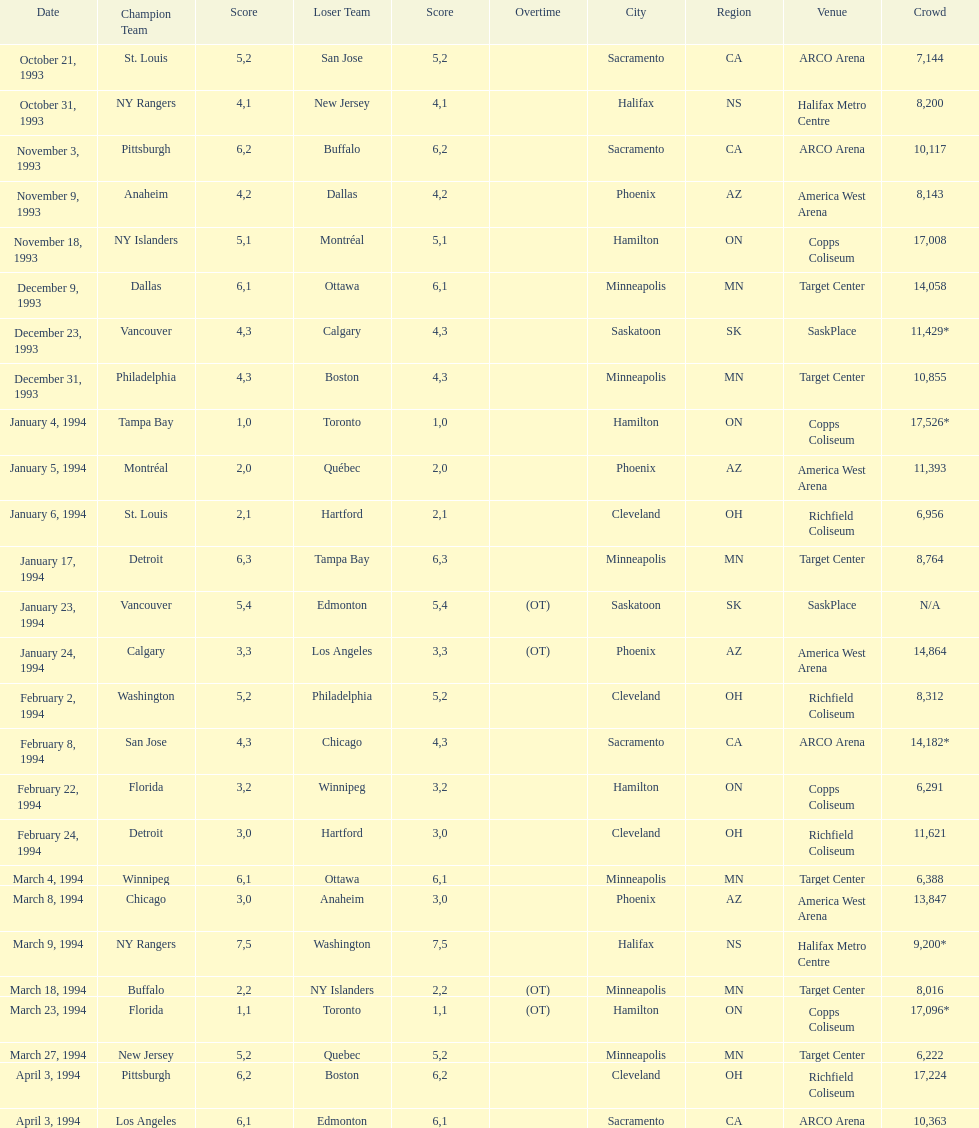Who won the game the day before the january 5, 1994 game? Tampa Bay. 